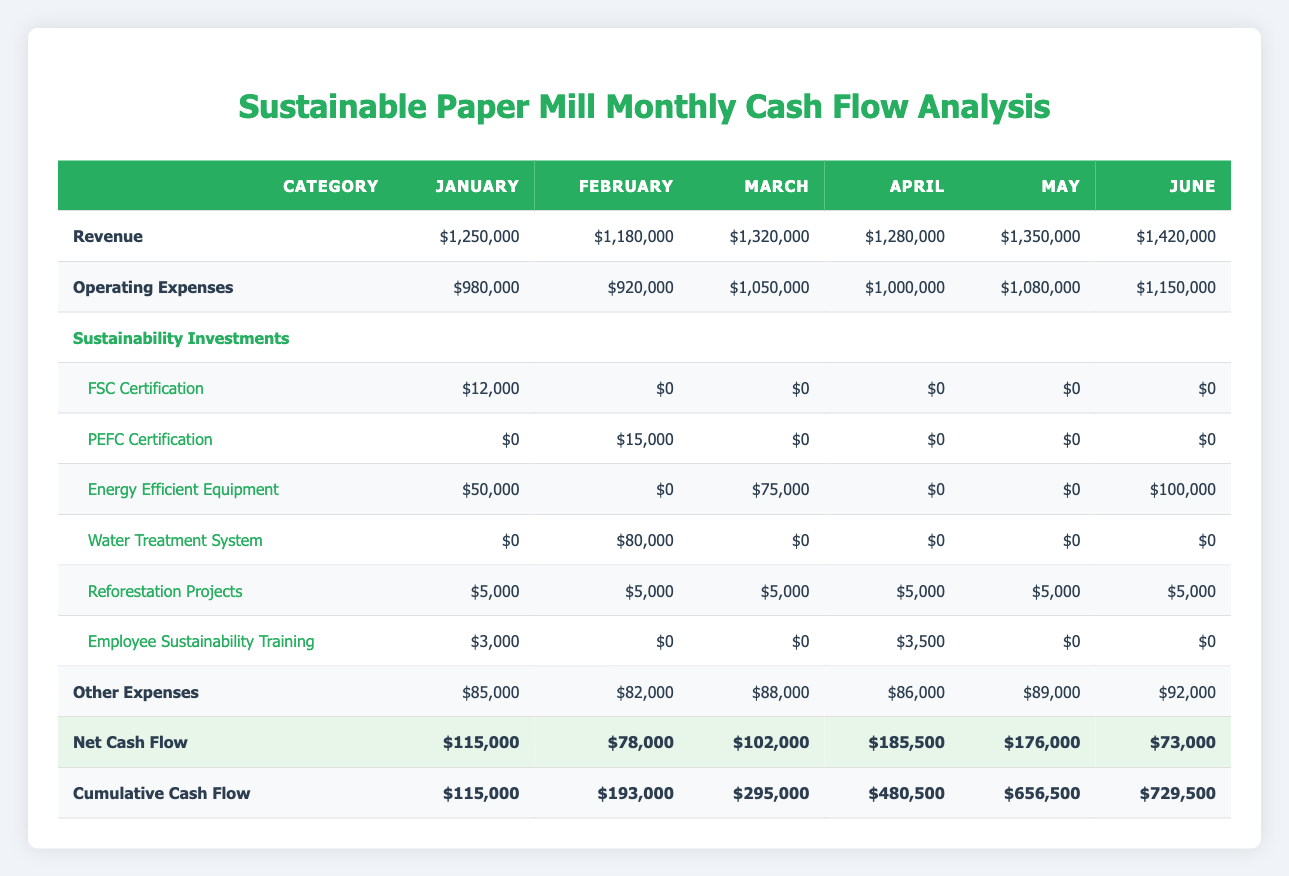What is the total revenue for March? Referring to the revenue row for March, the total revenue recorded is 1,320,000.
Answer: 1,320,000 How much did the paper mill invest in sustainability projects in February? By reviewing the sustainability investment rows for February, the investments are: PEFC Certification 15,000, Water Treatment System 80,000, Reforestation Projects 5,000, and Employee Sustainability Training 0. Summing these amounts gives: 15,000 + 80,000 + 5,000 + 0 = 100,000.
Answer: 100,000 Did the net cash flow increase from January to February? The net cash flow for January is 115,000 and for February is 78,000. Since 78,000 is less than 115,000, the net cash flow did not increase.
Answer: No What are the total sustainability investments made in June? The sustainability investments in June are: Energy Efficient Equipment 100,000, Reforestation Projects 5,000, and Employee Sustainability Training 0. Summing these amounts gives: 100,000 + 5,000 + 0 = 105,000.
Answer: 105,000 What is the cumulative cash flow at the end of April? The cumulative cash flow for April is directly noted in the table as 480,500.
Answer: 480,500 How does the operating expense in May compare to the net cash flow in the same month? The operating expenses in May are 1,080,000, while the net cash flow for May is 176,000. Since 176,000 is significantly less than 1,080,000, operating expenses are higher.
Answer: Operating expenses are higher What is the average sustainability investment for the first half of the year (January to June)? The total sustainability investments in the first half are: January 12,000 + February 15,000 + March 75,000 + April 0 + May 0 + June 100,000 + (February 80,000 for Water Treatment) + (January 5,000 + February 5,000 + March 5,000 + April 5,000 + May 5,000 + June 5,000) + (January 3,000 + April 3,500) = 12,000 + 15,000 + 75,000 + 0 + 0 + 100,000 + 80,000 + 30,000 = 312,000. The average is 312,000 / 6 = 52,000.
Answer: 52,000 Is the net cash flow greater in April or May? The net cash flow for April is 185,500 and for May is 176,000. Since 185,500 is greater than 176,000, the net cash flow is greater in April.
Answer: April is greater 